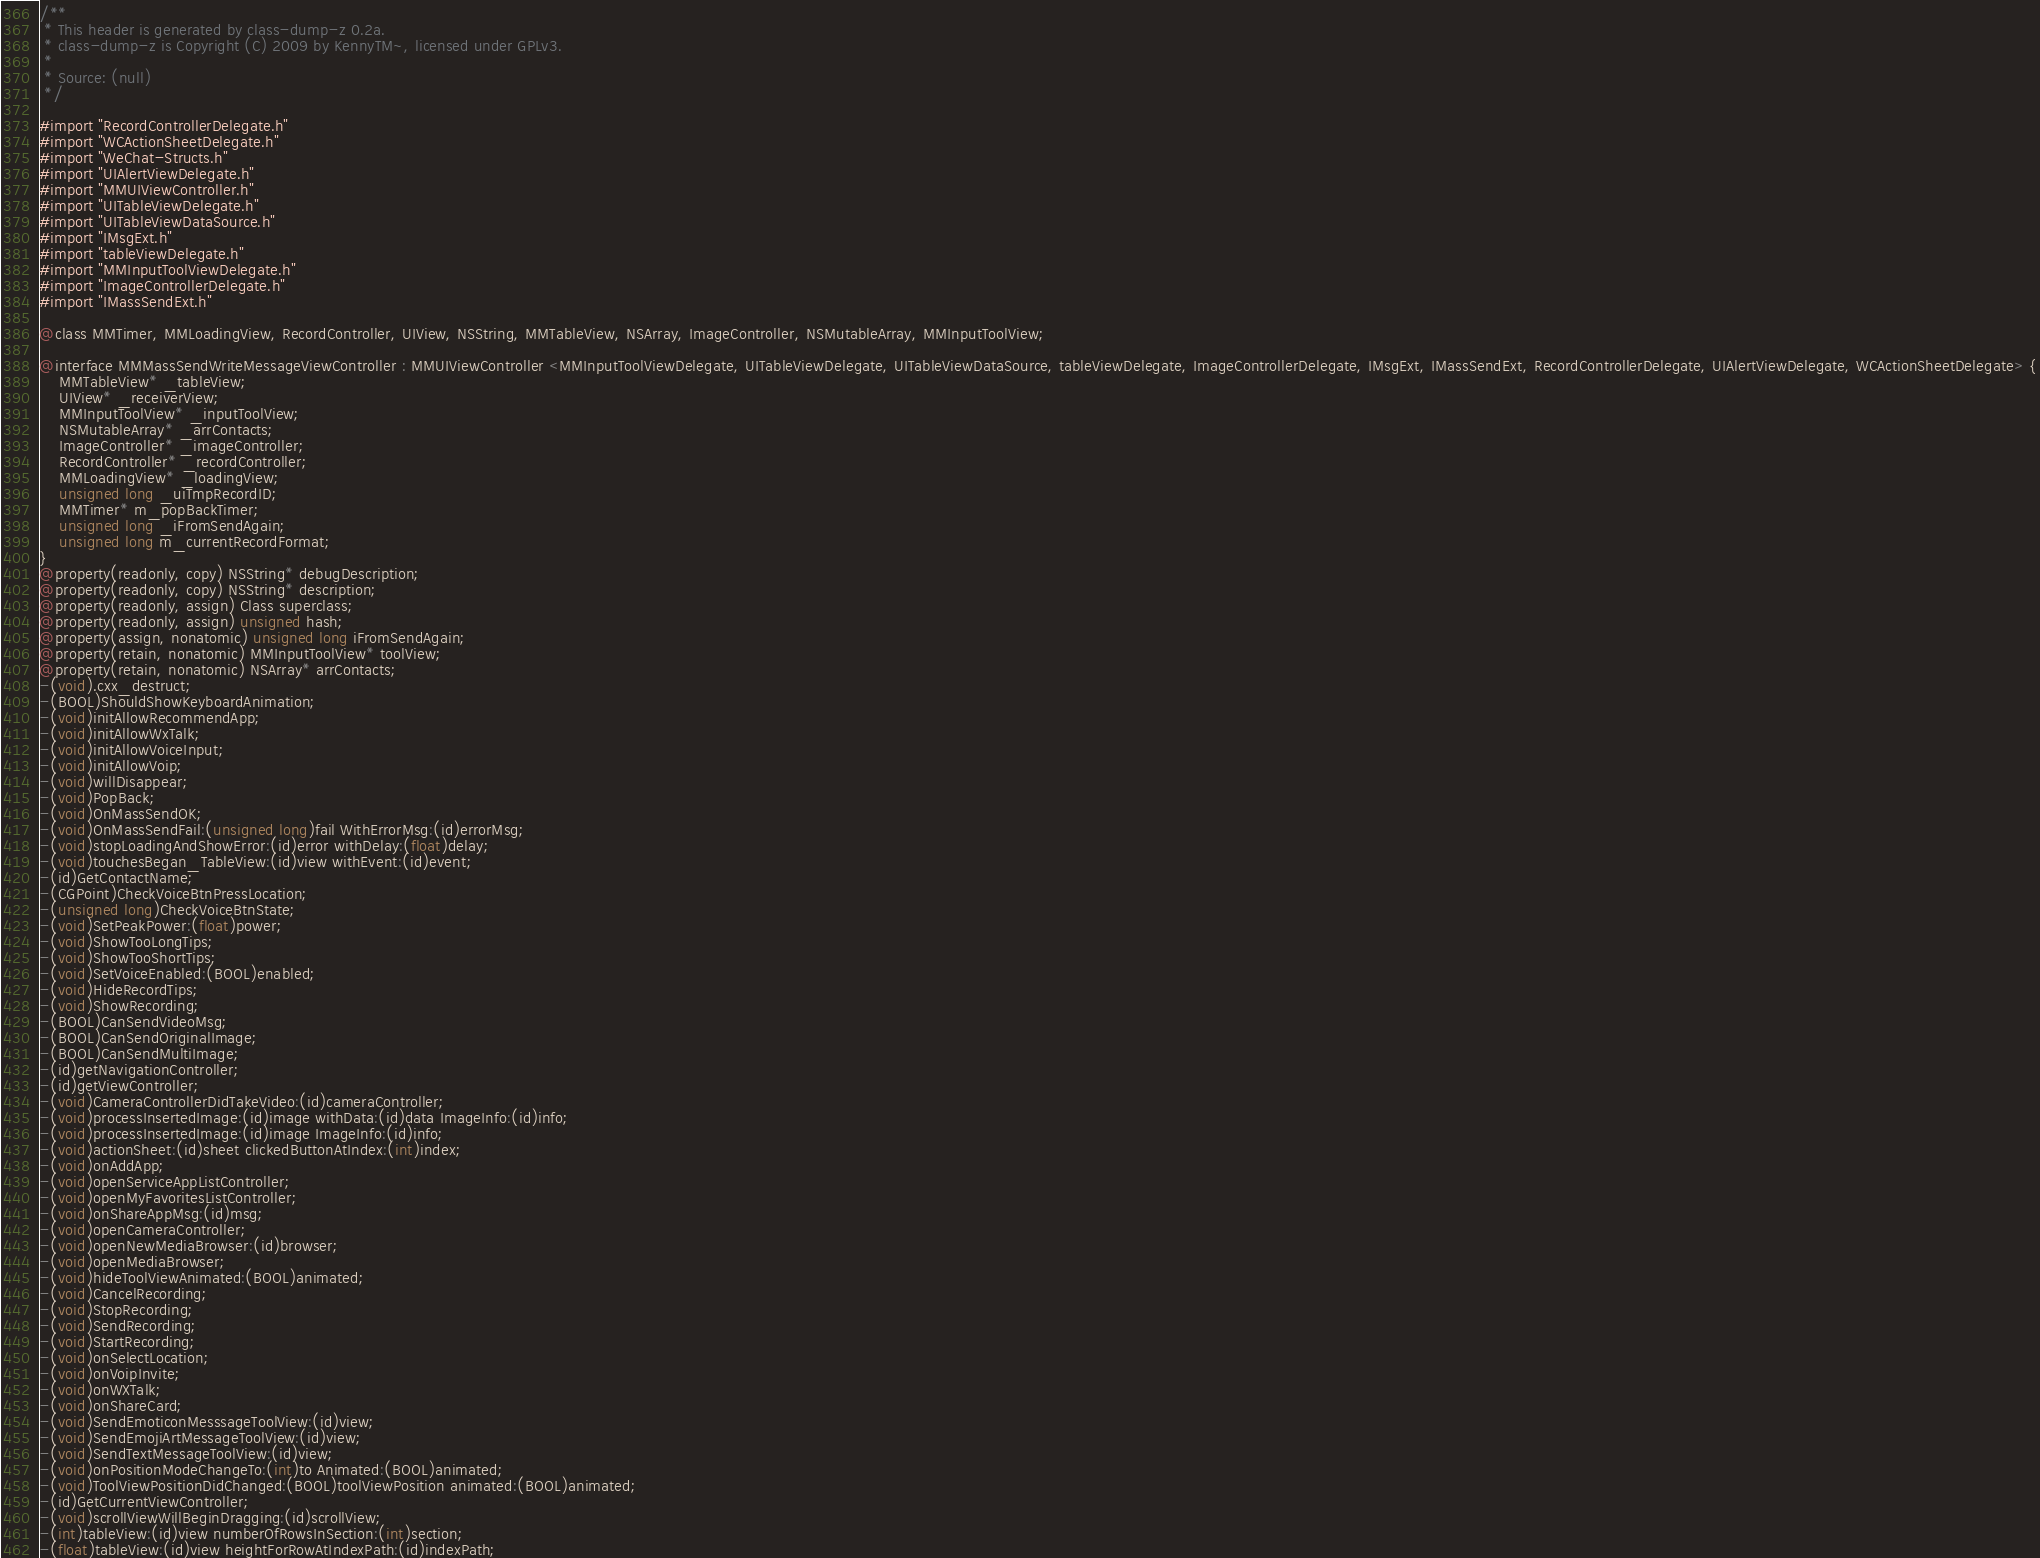<code> <loc_0><loc_0><loc_500><loc_500><_C_>/**
 * This header is generated by class-dump-z 0.2a.
 * class-dump-z is Copyright (C) 2009 by KennyTM~, licensed under GPLv3.
 *
 * Source: (null)
 */

#import "RecordControllerDelegate.h"
#import "WCActionSheetDelegate.h"
#import "WeChat-Structs.h"
#import "UIAlertViewDelegate.h"
#import "MMUIViewController.h"
#import "UITableViewDelegate.h"
#import "UITableViewDataSource.h"
#import "IMsgExt.h"
#import "tableViewDelegate.h"
#import "MMInputToolViewDelegate.h"
#import "ImageControllerDelegate.h"
#import "IMassSendExt.h"

@class MMTimer, MMLoadingView, RecordController, UIView, NSString, MMTableView, NSArray, ImageController, NSMutableArray, MMInputToolView;

@interface MMMassSendWriteMessageViewController : MMUIViewController <MMInputToolViewDelegate, UITableViewDelegate, UITableViewDataSource, tableViewDelegate, ImageControllerDelegate, IMsgExt, IMassSendExt, RecordControllerDelegate, UIAlertViewDelegate, WCActionSheetDelegate> {
	MMTableView* _tableView;
	UIView* _receiverView;
	MMInputToolView* _inputToolView;
	NSMutableArray* _arrContacts;
	ImageController* _imageController;
	RecordController* _recordController;
	MMLoadingView* _loadingView;
	unsigned long _uiTmpRecordID;
	MMTimer* m_popBackTimer;
	unsigned long _iFromSendAgain;
	unsigned long m_currentRecordFormat;
}
@property(readonly, copy) NSString* debugDescription;
@property(readonly, copy) NSString* description;
@property(readonly, assign) Class superclass;
@property(readonly, assign) unsigned hash;
@property(assign, nonatomic) unsigned long iFromSendAgain;
@property(retain, nonatomic) MMInputToolView* toolView;
@property(retain, nonatomic) NSArray* arrContacts;
-(void).cxx_destruct;
-(BOOL)ShouldShowKeyboardAnimation;
-(void)initAllowRecommendApp;
-(void)initAllowWxTalk;
-(void)initAllowVoiceInput;
-(void)initAllowVoip;
-(void)willDisappear;
-(void)PopBack;
-(void)OnMassSendOK;
-(void)OnMassSendFail:(unsigned long)fail WithErrorMsg:(id)errorMsg;
-(void)stopLoadingAndShowError:(id)error withDelay:(float)delay;
-(void)touchesBegan_TableView:(id)view withEvent:(id)event;
-(id)GetContactName;
-(CGPoint)CheckVoiceBtnPressLocation;
-(unsigned long)CheckVoiceBtnState;
-(void)SetPeakPower:(float)power;
-(void)ShowTooLongTips;
-(void)ShowTooShortTips;
-(void)SetVoiceEnabled:(BOOL)enabled;
-(void)HideRecordTips;
-(void)ShowRecording;
-(BOOL)CanSendVideoMsg;
-(BOOL)CanSendOriginalImage;
-(BOOL)CanSendMultiImage;
-(id)getNavigationController;
-(id)getViewController;
-(void)CameraControllerDidTakeVideo:(id)cameraController;
-(void)processInsertedImage:(id)image withData:(id)data ImageInfo:(id)info;
-(void)processInsertedImage:(id)image ImageInfo:(id)info;
-(void)actionSheet:(id)sheet clickedButtonAtIndex:(int)index;
-(void)onAddApp;
-(void)openServiceAppListController;
-(void)openMyFavoritesListController;
-(void)onShareAppMsg:(id)msg;
-(void)openCameraController;
-(void)openNewMediaBrowser:(id)browser;
-(void)openMediaBrowser;
-(void)hideToolViewAnimated:(BOOL)animated;
-(void)CancelRecording;
-(void)StopRecording;
-(void)SendRecording;
-(void)StartRecording;
-(void)onSelectLocation;
-(void)onVoipInvite;
-(void)onWXTalk;
-(void)onShareCard;
-(void)SendEmoticonMesssageToolView:(id)view;
-(void)SendEmojiArtMessageToolView:(id)view;
-(void)SendTextMessageToolView:(id)view;
-(void)onPositionModeChangeTo:(int)to Animated:(BOOL)animated;
-(void)ToolViewPositionDidChanged:(BOOL)toolViewPosition animated:(BOOL)animated;
-(id)GetCurrentViewController;
-(void)scrollViewWillBeginDragging:(id)scrollView;
-(int)tableView:(id)view numberOfRowsInSection:(int)section;
-(float)tableView:(id)view heightForRowAtIndexPath:(id)indexPath;</code> 